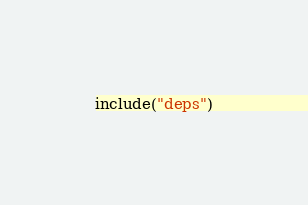<code> <loc_0><loc_0><loc_500><loc_500><_Kotlin_>include("deps")
</code> 